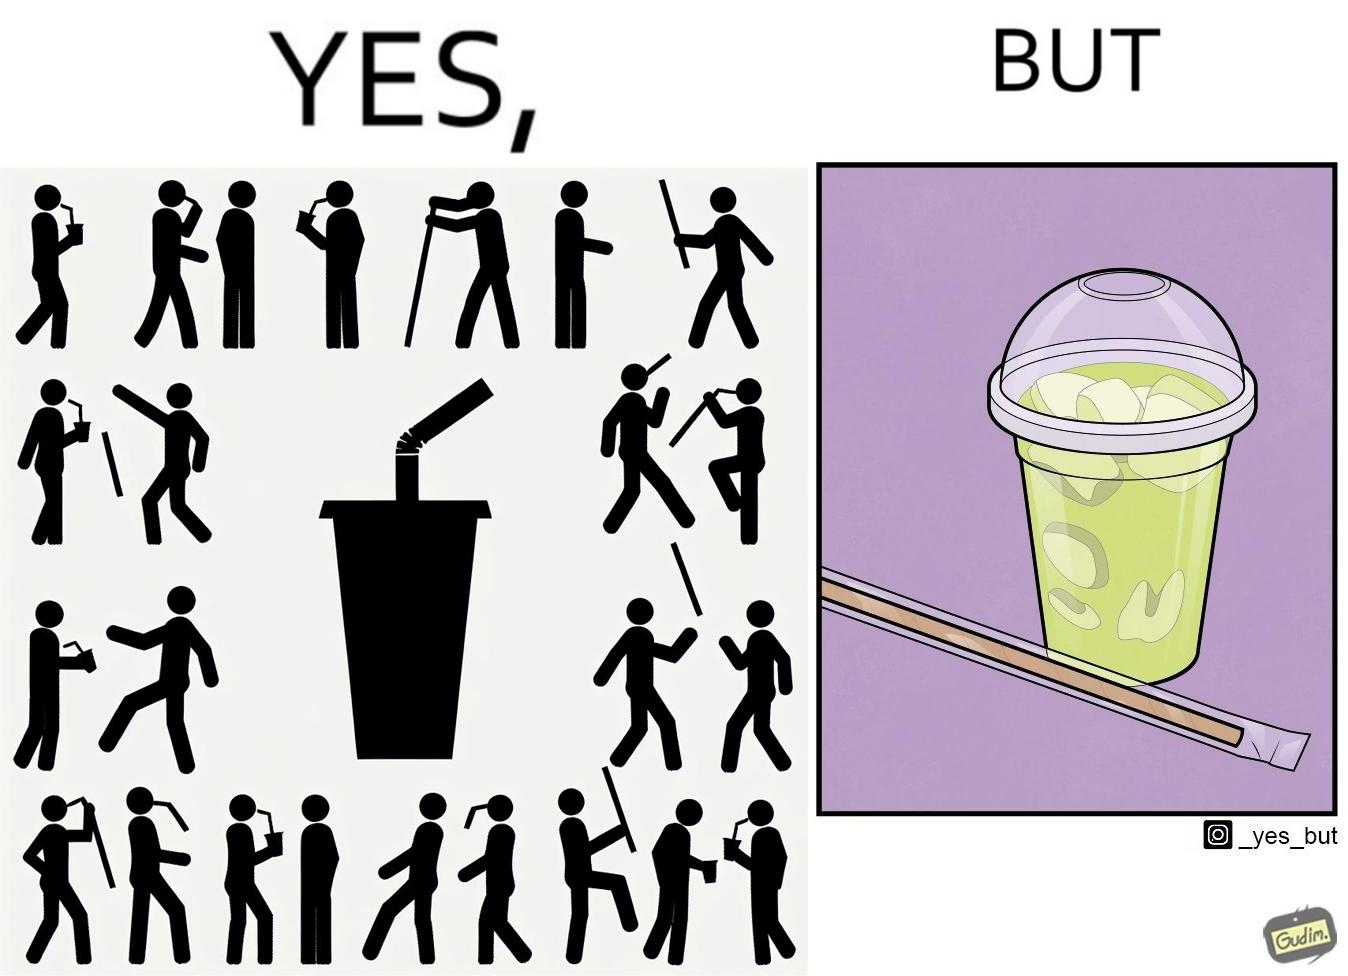What is the satirical meaning behind this image? The images are ironic since paper straws were invented to reduce use of plastic in the form of plastic straws. However, these straws come in plastic packages and are served with plastic cups, defeating  the purpose 